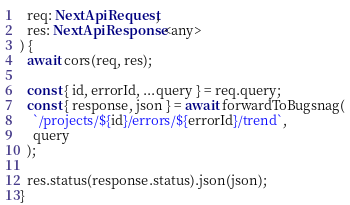Convert code to text. <code><loc_0><loc_0><loc_500><loc_500><_TypeScript_>  req: NextApiRequest,
  res: NextApiResponse<any>
) {
  await cors(req, res);

  const { id, errorId, ...query } = req.query;
  const { response, json } = await forwardToBugsnag(
    `/projects/${id}/errors/${errorId}/trend`,
    query
  );

  res.status(response.status).json(json);
}
</code> 